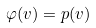<formula> <loc_0><loc_0><loc_500><loc_500>\varphi ( v ) = p ( v )</formula> 